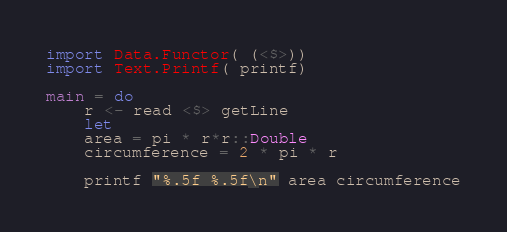<code> <loc_0><loc_0><loc_500><loc_500><_Haskell_>import Data.Functor( (<$>))
import Text.Printf( printf)

main = do
    r <- read <$> getLine
    let
	area = pi * r*r::Double
	circumference = 2 * pi * r

    printf "%.5f %.5f\n" area circumference

</code> 